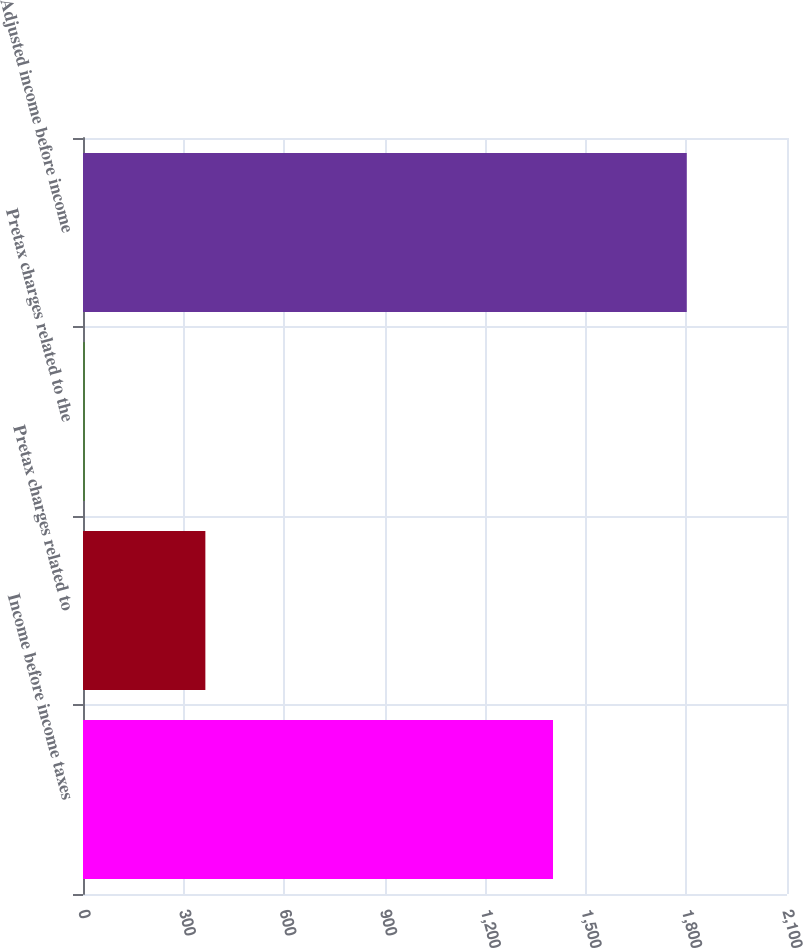<chart> <loc_0><loc_0><loc_500><loc_500><bar_chart><fcel>Income before income taxes<fcel>Pretax charges related to<fcel>Pretax charges related to the<fcel>Adjusted income before income<nl><fcel>1402<fcel>365<fcel>6<fcel>1801<nl></chart> 